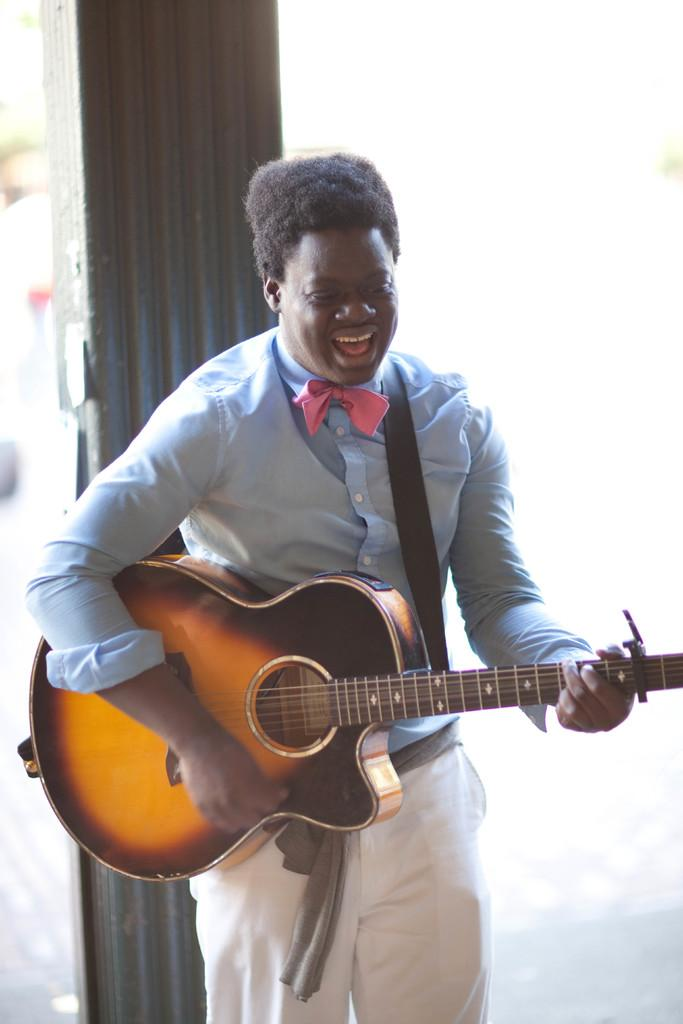What is the main subject of the image? There is a person in the image. What is the person doing in the image? The person is standing and playing a musical instrument. How does the person appear to feel in the image? The person is smiling, which suggests they are happy or enjoying themselves. Can you tell me how many cars are parked next to the crib in the image? There is no crib or cars present in the image; it features a person playing a musical instrument. What type of mother is shown interacting with the person in the image? There is no mother present in the image; it only features a person playing a musical instrument. 